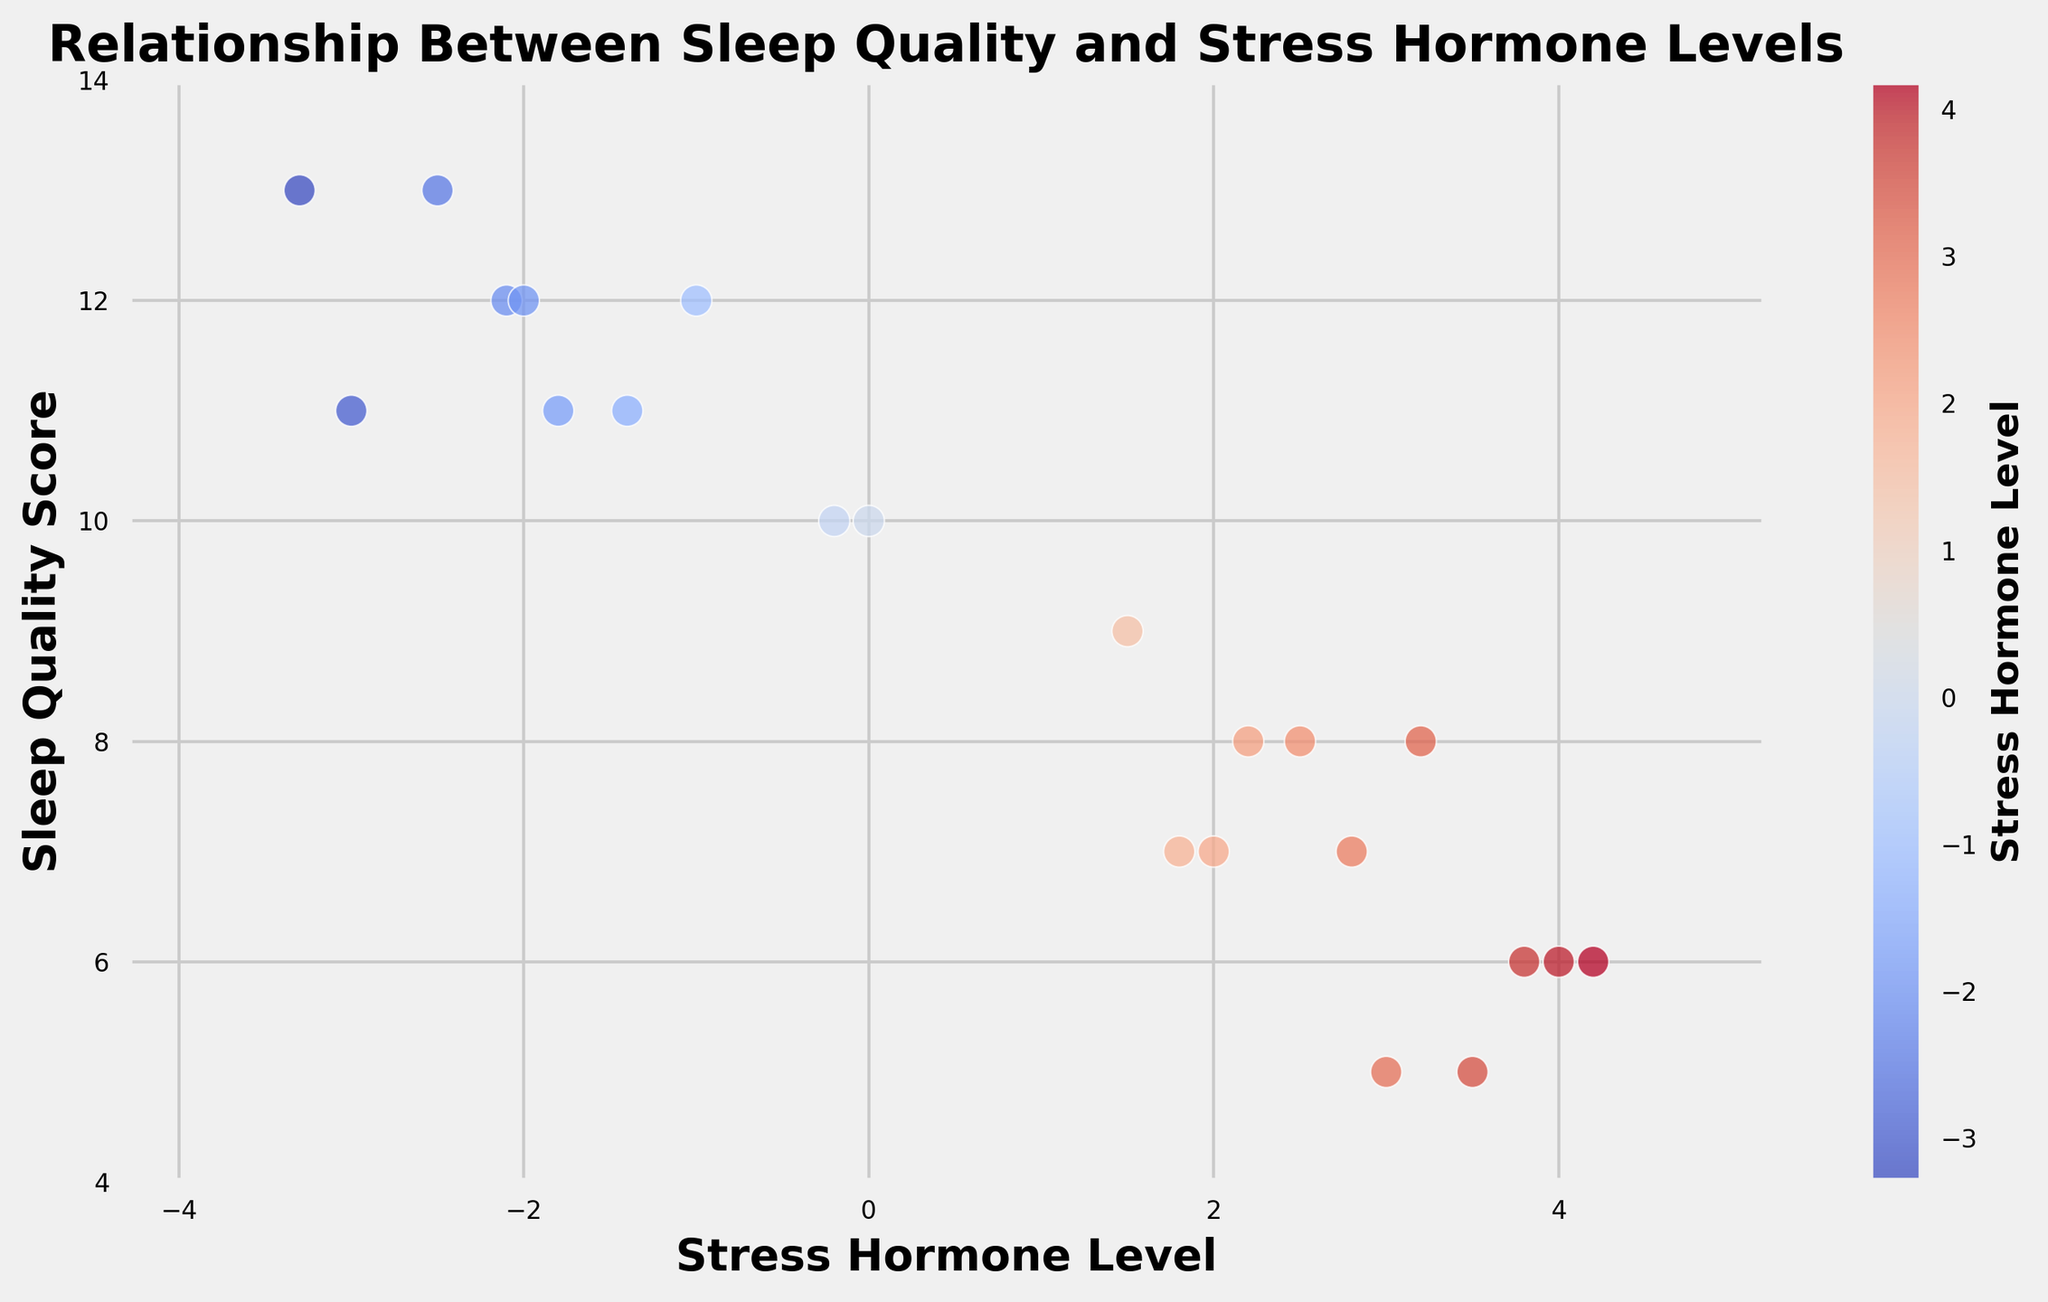What is the general trend between stress hormone levels and sleep quality scores? By looking at the scatter plot, we can observe that higher stress hormone levels correspond to lower sleep quality scores and vice versa. This indicates a negative correlation between the two variables.
Answer: Negative correlation Are there any data points where the stress hormone level is negative and the sleep quality score is greater than 10? Observing the scatter plot, we see several data points with negative stress hormone levels that have sleep quality scores greater than 10, such as (-2.1, 12), (-3.3, 13), (-1.4, 11), etc.
Answer: Yes Which data point has the highest stress hormone level and what is its sleep quality score? Scanning the scatter plot, we find that the highest stress hormone level is 4.2, and its corresponding sleep quality score is 6.
Answer: (4.2, 6) What is the range of sleep quality scores for data points where stress hormone levels are below zero? Looking at the scatter plot, the sleep quality scores for negative stress hormone levels range from 10 to 13.
Answer: 10 to 13 Is the color of the data points with negative stress hormone levels generally the same as the color of those with positive stress hormone levels? From the scatter plot, we notice that negative stress hormone levels are represented by a different color hue compared to positive stress hormone levels, indicating a visual distinction.
Answer: No How does the sleep quality score change as stress hormone level increases from -3.3 to 4.2? As we move from a stress hormone level of -3.3 to 4.2, sleep quality scores generally decrease from 13 to 6, showing an inverse relationship.
Answer: Decrease What is the sleep quality score for a stress hormone level of 0.0? Checking the scatter plot, the sleep quality score for a stress hormone level of 0.0 is observed to be 10.
Answer: 10 Which sleep quality score has the maximum variability in stress hormone levels associated with it? By examining the scatter plot, it is seen that the sleep quality score of 12 has associated stress hormone levels ranging from -2.1 to -1.0, showing the maximum spread.
Answer: 12 Comparing stress hormone levels of -1.0 and 4.0, which has a higher sleep quality score and what are the scores? From the scatter plot, a stress hormone level of -1.0 has a sleep quality score of 12, whereas 4.0 has a sleep quality score of 6. Thus, the higher score is at -1.0.
Answer: -1.0: 12, 4.0: 6 